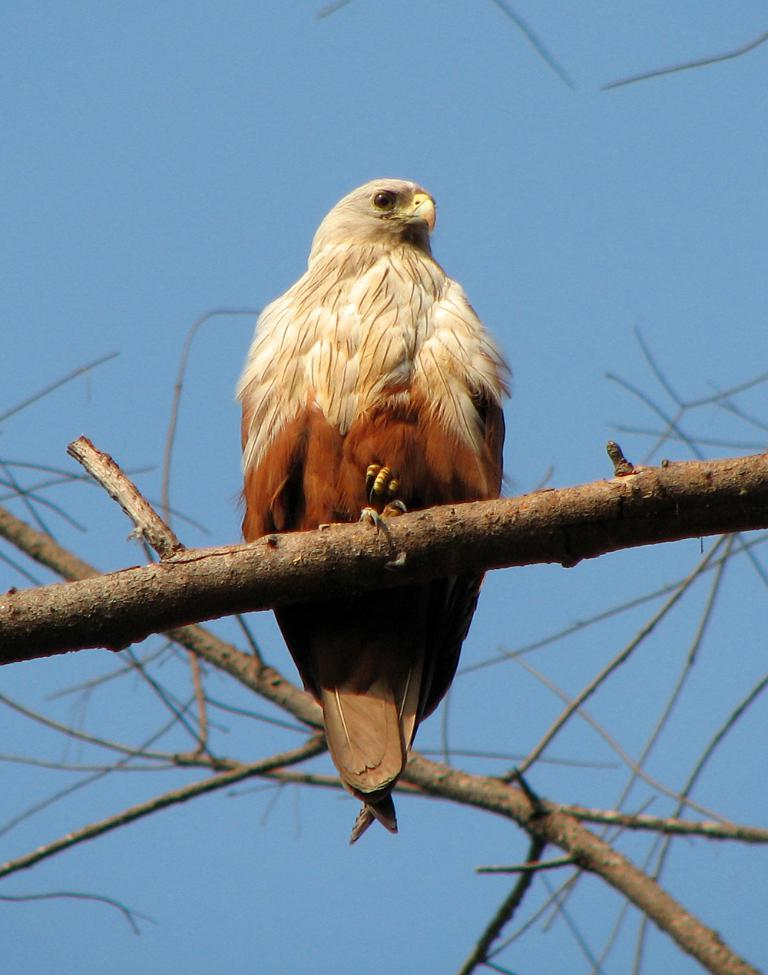What animal can be seen in the image? There is an eagle in the image. Where is the eagle located in the image? The eagle is standing on a tree branch. What type of plant is present in the image? There is a tree in the image. What can be seen in the background of the image? The sky is visible in the background of the image. What type of carpenter is working on the boundary in the image? There is no carpenter or boundary present in the image; it features an eagle standing on a tree branch. How does the airplane affect the eagle's behavior in the image? There is no airplane present in the image, so its behavior is not affected by one. 